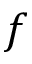<formula> <loc_0><loc_0><loc_500><loc_500>f</formula> 